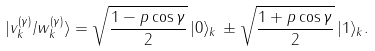<formula> <loc_0><loc_0><loc_500><loc_500>| v _ { k } ^ { ( \gamma ) } / w _ { k } ^ { ( \gamma ) } \rangle = \sqrt { \frac { 1 - p \cos \gamma } { 2 } } \, | 0 \rangle _ { k } \, \pm \sqrt { \frac { 1 + p \cos \gamma } { 2 } } \, | 1 \rangle _ { k } .</formula> 